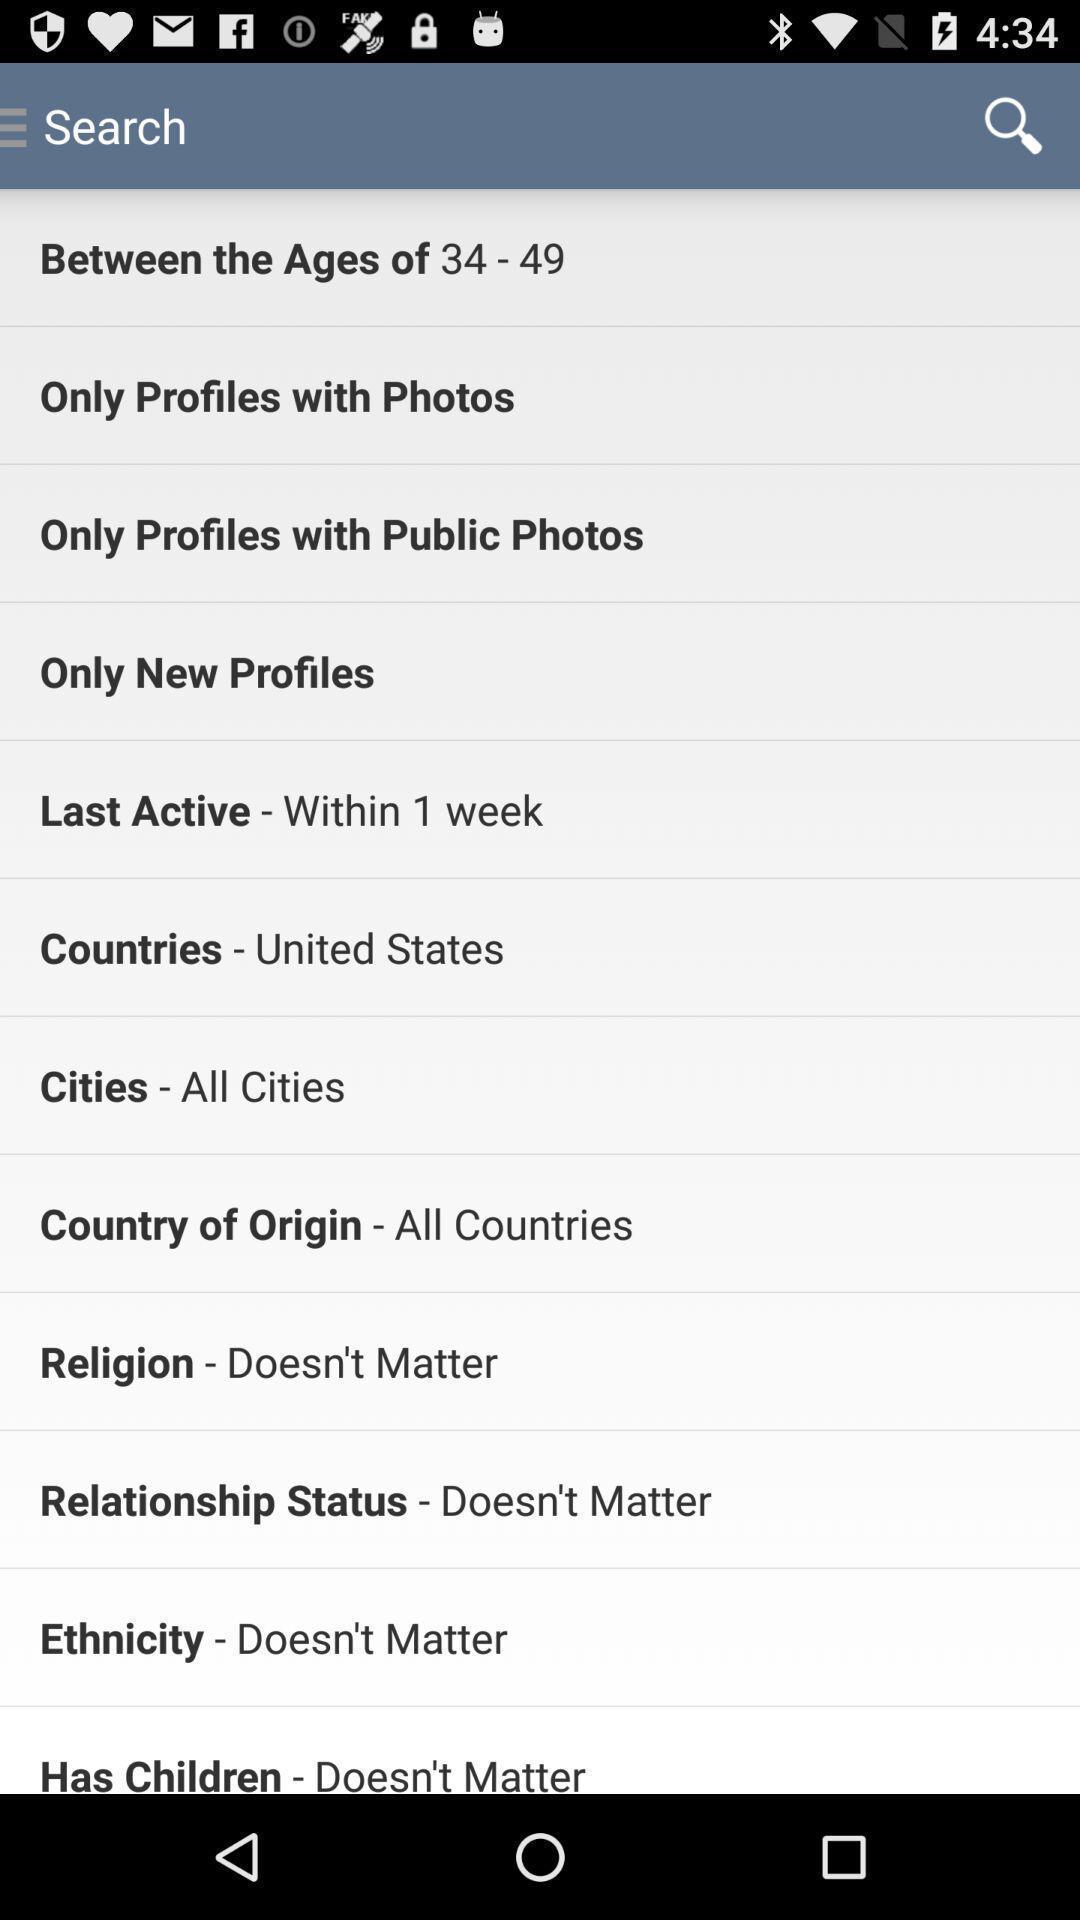Describe the content in this image. Search page displaying of an dating application. 